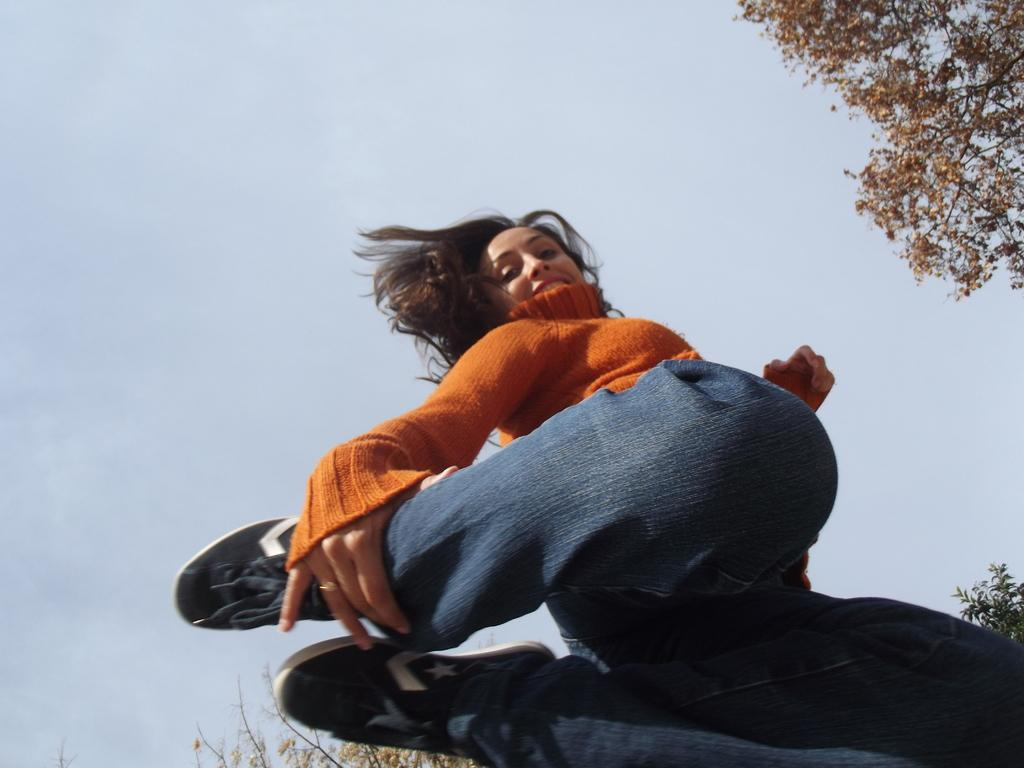Who is present in the image? There is a woman in the image. What is the woman wearing on her upper body? The woman is wearing an orange t-shirt. What is the woman wearing on her lower body? The woman is wearing blue jeans. What type of footwear is the woman wearing? The woman is wearing black shoes. What can be seen in the background of the image? There are trees and the sky visible in the background of the image. What type of rice is being cooked in the image? There is no rice present in the image; it features a woman wearing an orange t-shirt, blue jeans, and black shoes, with trees and the sky visible in the background. 